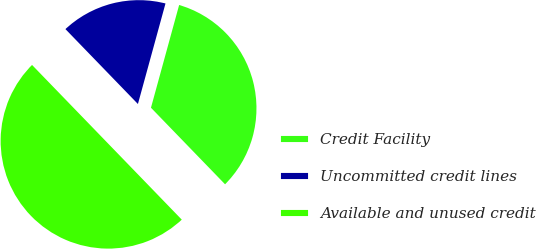Convert chart to OTSL. <chart><loc_0><loc_0><loc_500><loc_500><pie_chart><fcel>Credit Facility<fcel>Uncommitted credit lines<fcel>Available and unused credit<nl><fcel>33.5%<fcel>16.5%<fcel>50.0%<nl></chart> 